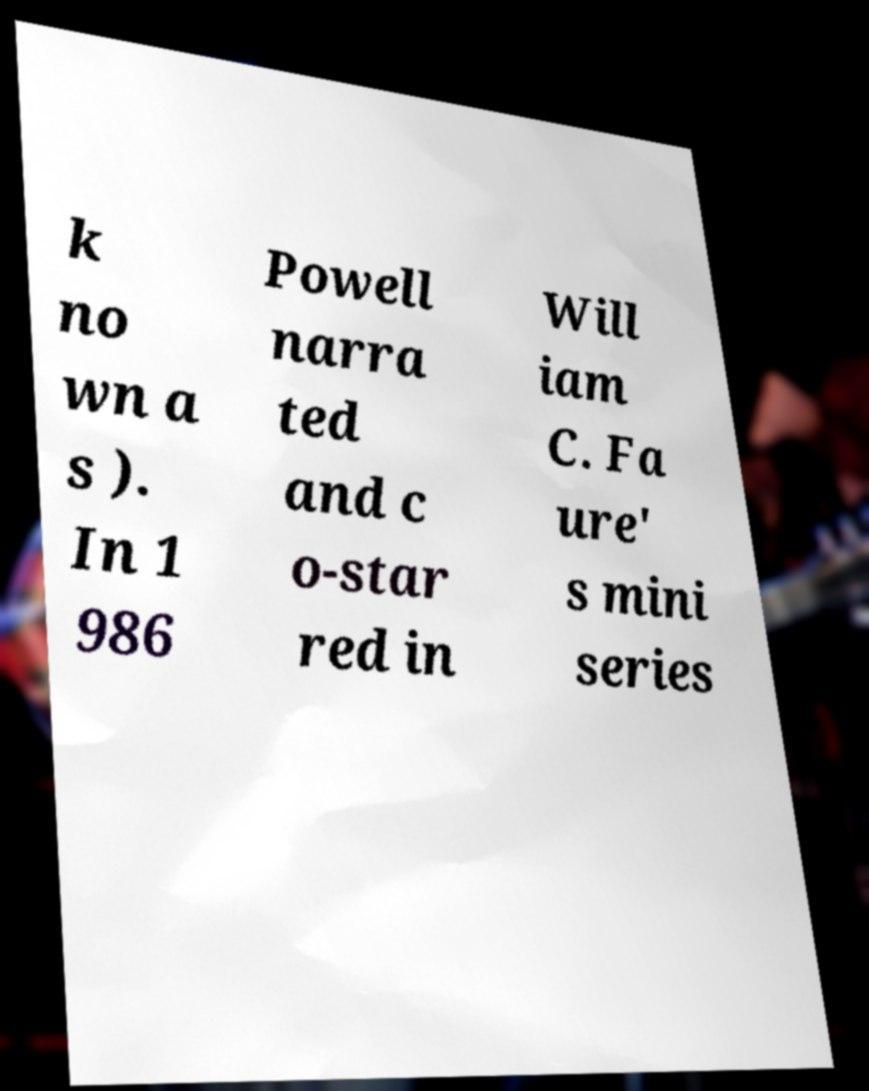I need the written content from this picture converted into text. Can you do that? k no wn a s ). In 1 986 Powell narra ted and c o-star red in Will iam C. Fa ure' s mini series 